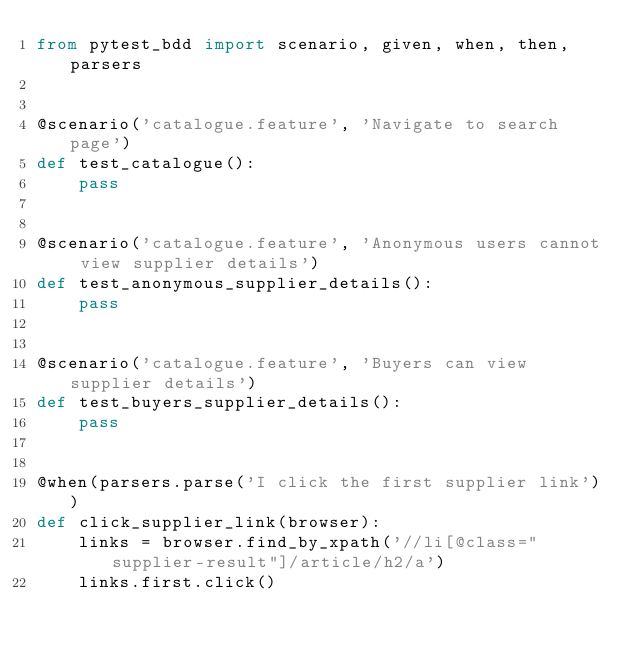Convert code to text. <code><loc_0><loc_0><loc_500><loc_500><_Python_>from pytest_bdd import scenario, given, when, then, parsers


@scenario('catalogue.feature', 'Navigate to search page')
def test_catalogue():
    pass


@scenario('catalogue.feature', 'Anonymous users cannot view supplier details')
def test_anonymous_supplier_details():
    pass


@scenario('catalogue.feature', 'Buyers can view supplier details')
def test_buyers_supplier_details():
    pass


@when(parsers.parse('I click the first supplier link'))
def click_supplier_link(browser):
    links = browser.find_by_xpath('//li[@class="supplier-result"]/article/h2/a')
    links.first.click()
</code> 